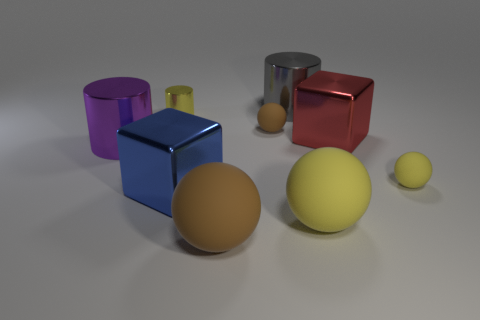How many matte things are either blue spheres or tiny yellow cylinders?
Make the answer very short. 0. The small yellow metallic thing is what shape?
Give a very brief answer. Cylinder. What is the material of the brown sphere that is the same size as the gray metal cylinder?
Ensure brevity in your answer.  Rubber. How many large objects are either yellow matte objects or purple metal cylinders?
Ensure brevity in your answer.  2. Is there a small object?
Ensure brevity in your answer.  Yes. There is a gray thing that is the same material as the small cylinder; what is its size?
Your answer should be compact. Large. Are the big purple thing and the blue block made of the same material?
Give a very brief answer. Yes. How many other things are made of the same material as the big purple cylinder?
Offer a very short reply. 4. What number of objects are both on the right side of the yellow metal thing and in front of the tiny brown matte object?
Keep it short and to the point. 5. What color is the tiny metal cylinder?
Provide a short and direct response. Yellow. 